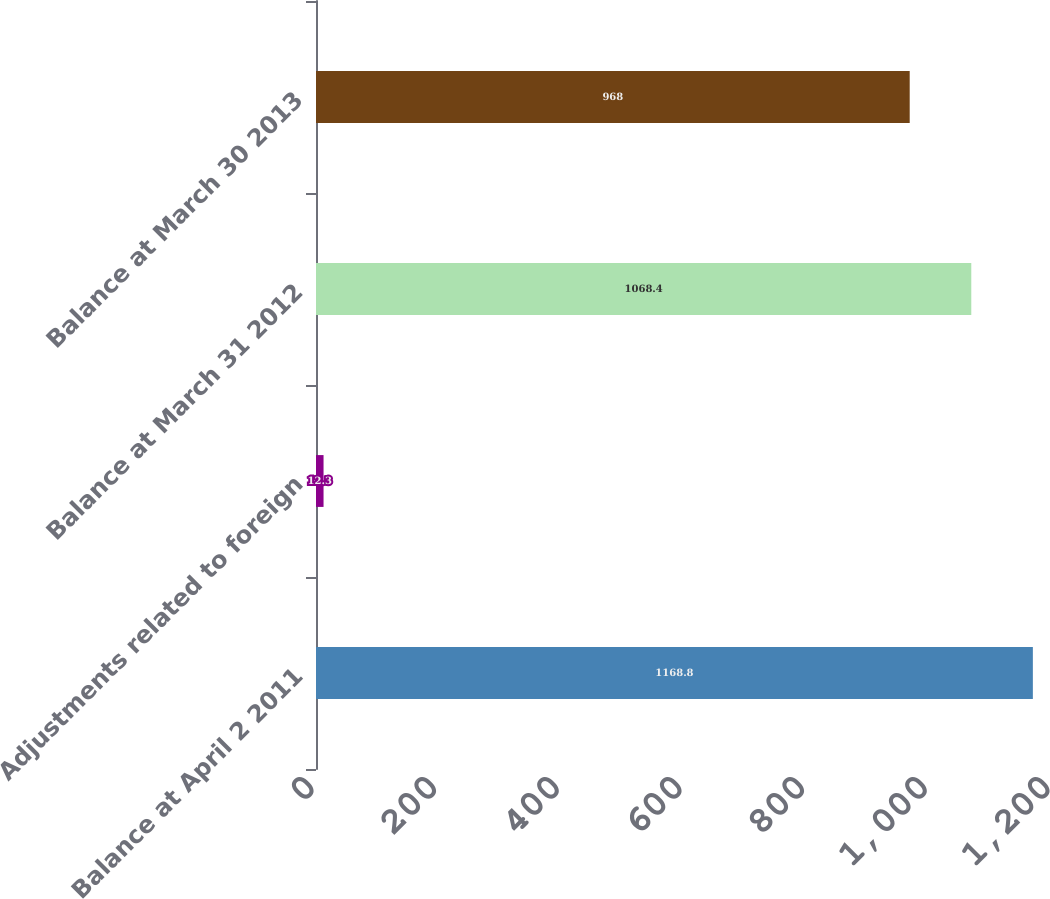Convert chart to OTSL. <chart><loc_0><loc_0><loc_500><loc_500><bar_chart><fcel>Balance at April 2 2011<fcel>Adjustments related to foreign<fcel>Balance at March 31 2012<fcel>Balance at March 30 2013<nl><fcel>1168.8<fcel>12.3<fcel>1068.4<fcel>968<nl></chart> 